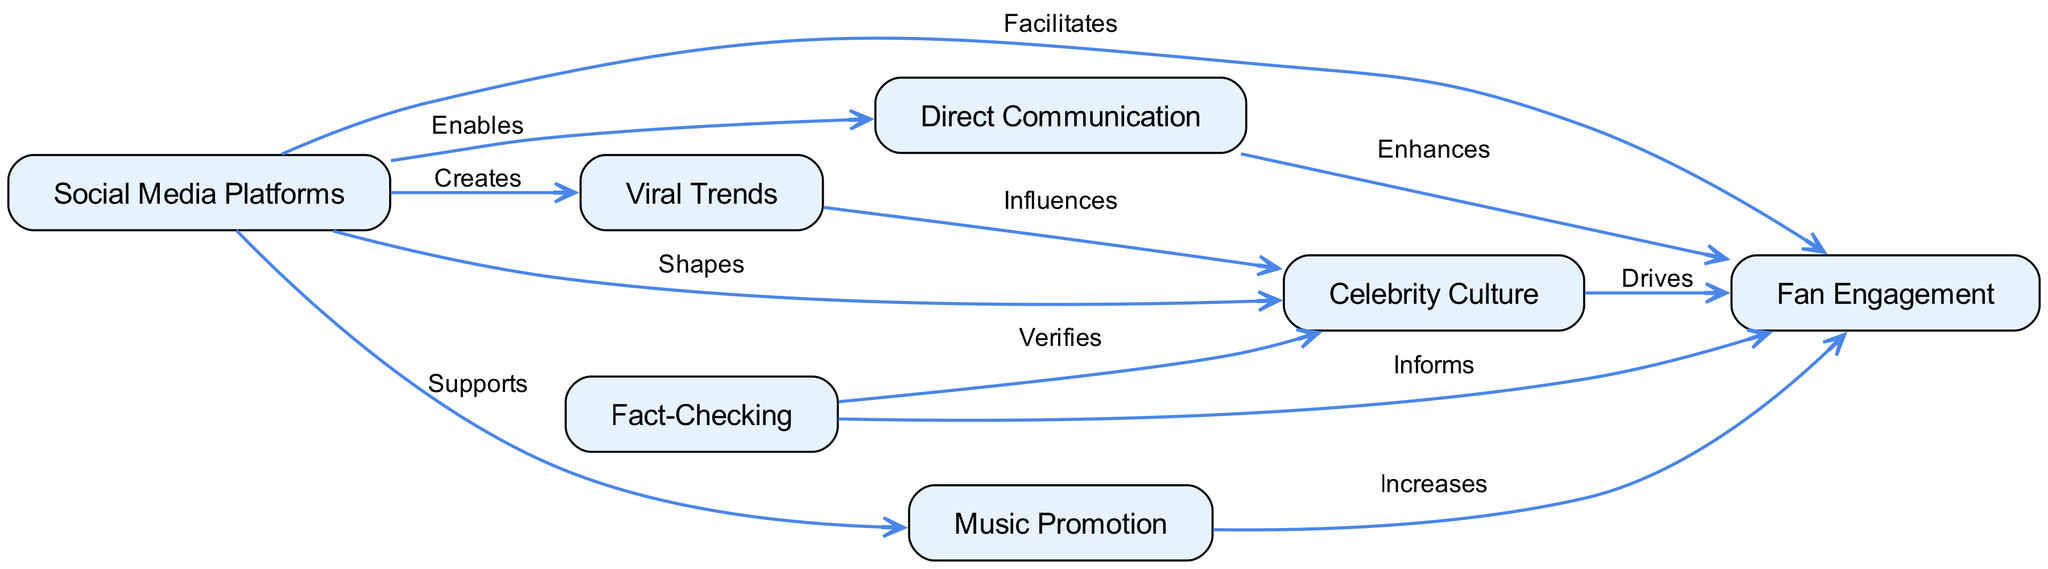What shapes celebrity culture according to the diagram? The diagram indicates that social media platforms shape celebrity culture. This is shown by the edge that connects the node "Social Media Platforms" to the node "Celebrity Culture" labeled "Shapes".
Answer: Social media platforms How many nodes are present in the concept map? By counting the distinct nodes represented in the diagram, we find there are seven nodes: Social Media Platforms, Celebrity Culture, Fan Engagement, Direct Communication, Viral Trends, Music Promotion, and Fact-Checking.
Answer: Seven What does direct communication enable in fan engagement? The diagram shows that direct communication, enabled by social media platforms, enhances fan engagement. This relation is represented by the edge from "Direct Communication" to "Fan Engagement" labeled "Enhances".
Answer: Enhances Which element influences celebrity culture through viral trends? The diagram connects the node "Viral Trends" to "Celebrity Culture", demonstrating that viral trends influence celebrity culture. This is indicated by the edge labeled "Influences".
Answer: Viral trends What role does fact-checking play in celebrity culture? The diagram specifies that fact-checking verifies aspects of celebrity culture. This is shown by the connection between "Fact-Checking" and "Celebrity Culture" labeled "Verifies".
Answer: Verifies How does music promotion affect fan engagement? The concept map indicates that music promotion, supported by social media platforms, increases fan engagement. This relationship is represented by the edge labeled "Increases" connecting "Music Promotion" to "Fan Engagement".
Answer: Increases What creates viral trends according to the diagram? Social media platforms create viral trends, as indicated by the edge connecting these two nodes in the diagram labeled "Creates".
Answer: Social media platforms What does fan engagement increase through? The diagram shows that fan engagement increases through music promotion, which is supported by social media platforms. This connection is depicted in the edge labeled "Increases".
Answer: Music promotion 